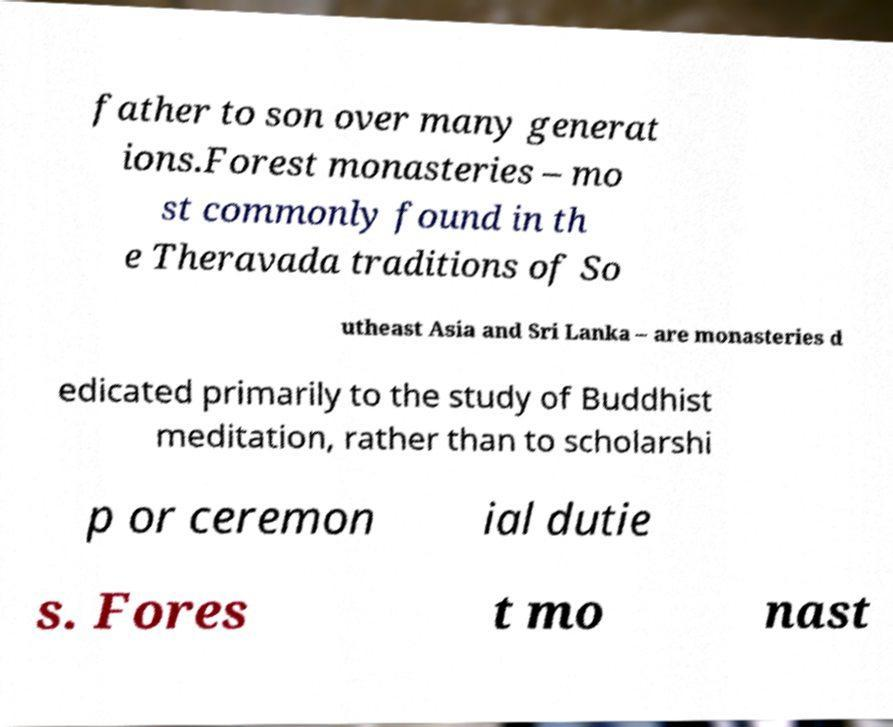Could you extract and type out the text from this image? father to son over many generat ions.Forest monasteries – mo st commonly found in th e Theravada traditions of So utheast Asia and Sri Lanka – are monasteries d edicated primarily to the study of Buddhist meditation, rather than to scholarshi p or ceremon ial dutie s. Fores t mo nast 